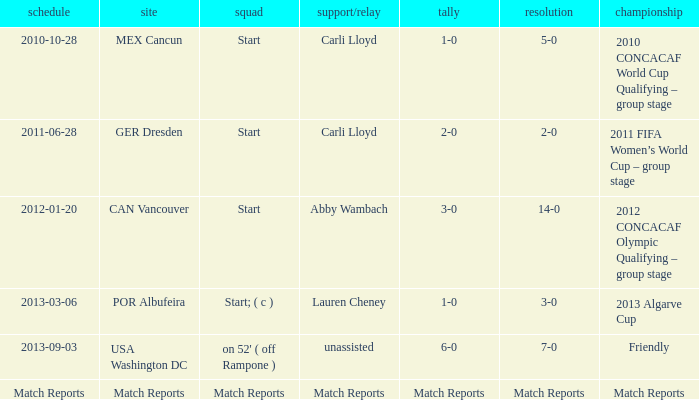Where has a score of match reports? Match Reports. Write the full table. {'header': ['schedule', 'site', 'squad', 'support/relay', 'tally', 'resolution', 'championship'], 'rows': [['2010-10-28', 'MEX Cancun', 'Start', 'Carli Lloyd', '1-0', '5-0', '2010 CONCACAF World Cup Qualifying – group stage'], ['2011-06-28', 'GER Dresden', 'Start', 'Carli Lloyd', '2-0', '2-0', '2011 FIFA Women’s World Cup – group stage'], ['2012-01-20', 'CAN Vancouver', 'Start', 'Abby Wambach', '3-0', '14-0', '2012 CONCACAF Olympic Qualifying – group stage'], ['2013-03-06', 'POR Albufeira', 'Start; ( c )', 'Lauren Cheney', '1-0', '3-0', '2013 Algarve Cup'], ['2013-09-03', 'USA Washington DC', "on 52' ( off Rampone )", 'unassisted', '6-0', '7-0', 'Friendly'], ['Match Reports', 'Match Reports', 'Match Reports', 'Match Reports', 'Match Reports', 'Match Reports', 'Match Reports']]} 